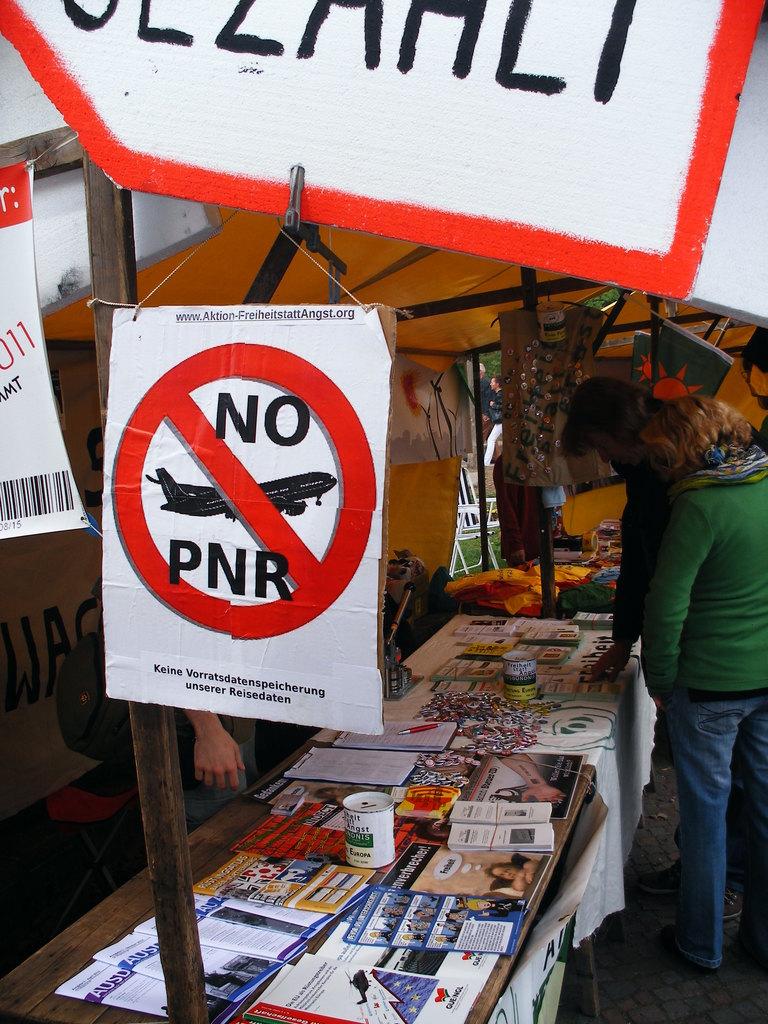What does the sign say?
Ensure brevity in your answer.  No pnr. 